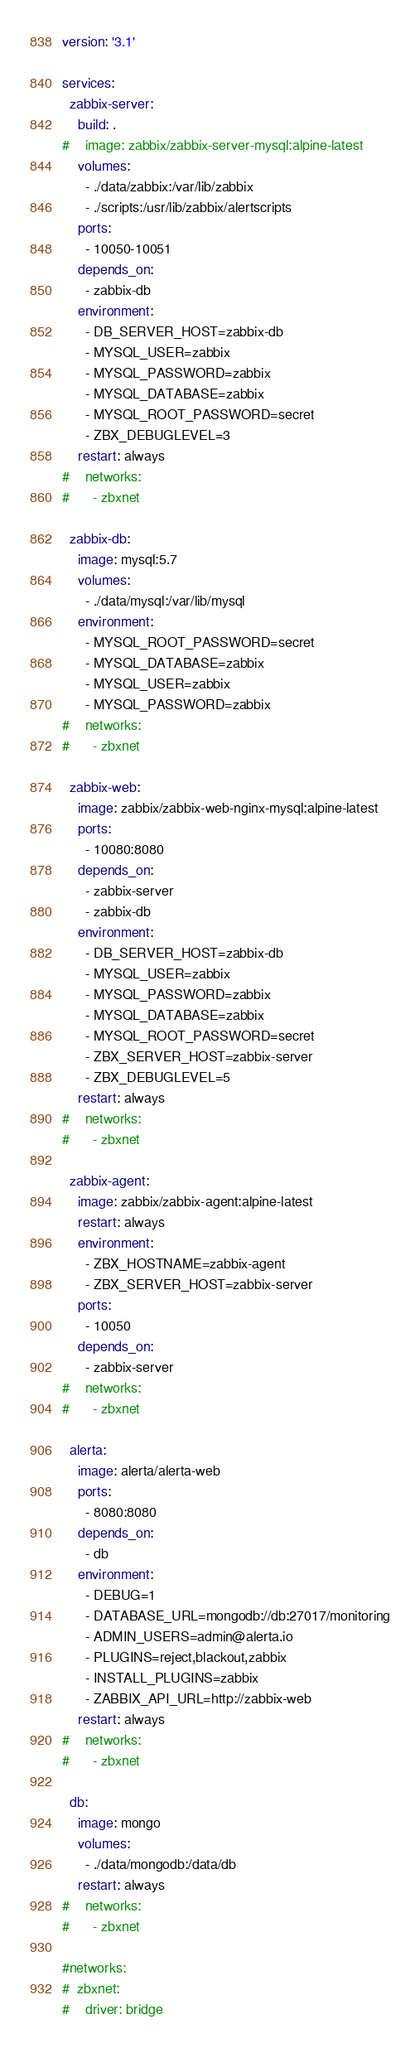<code> <loc_0><loc_0><loc_500><loc_500><_YAML_>version: '3.1'

services:
  zabbix-server:
    build: .
#    image: zabbix/zabbix-server-mysql:alpine-latest
    volumes:
      - ./data/zabbix:/var/lib/zabbix
      - ./scripts:/usr/lib/zabbix/alertscripts
    ports:
      - 10050-10051
    depends_on:
      - zabbix-db
    environment:
      - DB_SERVER_HOST=zabbix-db
      - MYSQL_USER=zabbix
      - MYSQL_PASSWORD=zabbix
      - MYSQL_DATABASE=zabbix
      - MYSQL_ROOT_PASSWORD=secret
      - ZBX_DEBUGLEVEL=3
    restart: always
#    networks:
#      - zbxnet

  zabbix-db:
    image: mysql:5.7
    volumes:
      - ./data/mysql:/var/lib/mysql
    environment:
      - MYSQL_ROOT_PASSWORD=secret
      - MYSQL_DATABASE=zabbix
      - MYSQL_USER=zabbix
      - MYSQL_PASSWORD=zabbix
#    networks:
#      - zbxnet

  zabbix-web:
    image: zabbix/zabbix-web-nginx-mysql:alpine-latest
    ports:
      - 10080:8080
    depends_on:
      - zabbix-server
      - zabbix-db
    environment:
      - DB_SERVER_HOST=zabbix-db
      - MYSQL_USER=zabbix
      - MYSQL_PASSWORD=zabbix
      - MYSQL_DATABASE=zabbix
      - MYSQL_ROOT_PASSWORD=secret
      - ZBX_SERVER_HOST=zabbix-server
      - ZBX_DEBUGLEVEL=5
    restart: always
#    networks:
#      - zbxnet

  zabbix-agent:
    image: zabbix/zabbix-agent:alpine-latest
    restart: always
    environment:
      - ZBX_HOSTNAME=zabbix-agent
      - ZBX_SERVER_HOST=zabbix-server
    ports:
      - 10050
    depends_on:
      - zabbix-server
#    networks:
#      - zbxnet

  alerta:
    image: alerta/alerta-web
    ports:
      - 8080:8080
    depends_on:
      - db
    environment:
      - DEBUG=1
      - DATABASE_URL=mongodb://db:27017/monitoring
      - ADMIN_USERS=admin@alerta.io
      - PLUGINS=reject,blackout,zabbix
      - INSTALL_PLUGINS=zabbix
      - ZABBIX_API_URL=http://zabbix-web
    restart: always
#    networks:
#      - zbxnet

  db:
    image: mongo
    volumes:
      - ./data/mongodb:/data/db
    restart: always
#    networks:
#      - zbxnet

#networks:
#  zbxnet:
#    driver: bridge
</code> 